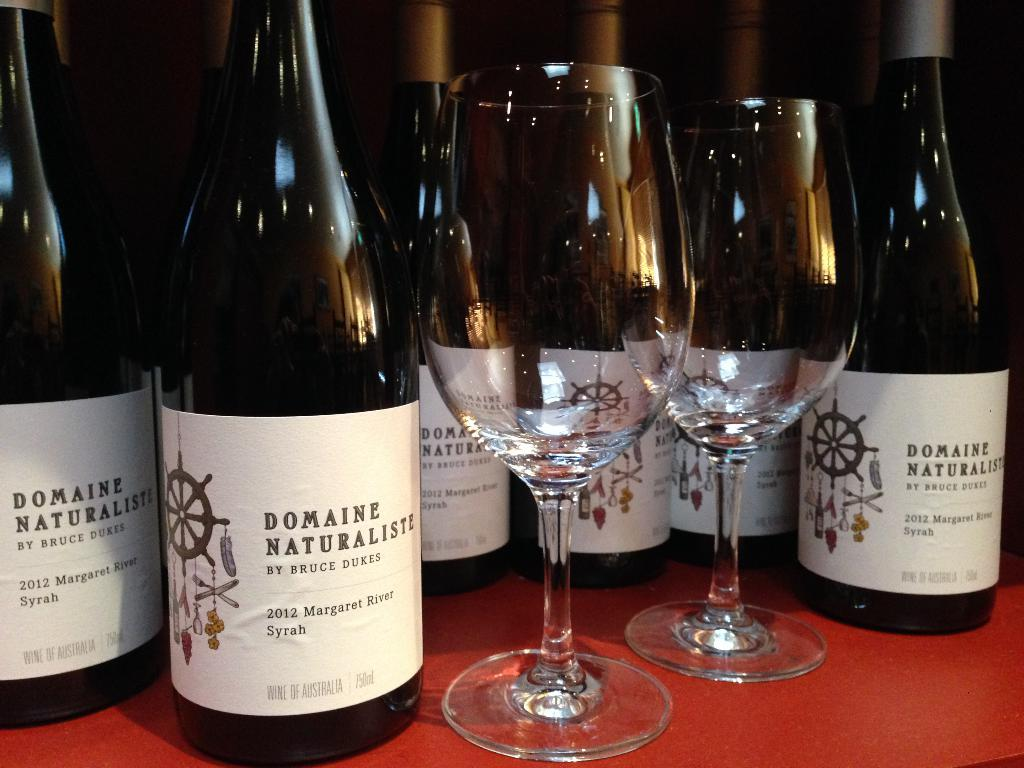<image>
Present a compact description of the photo's key features. The two crystal wineglasses are displayed with six bottles of Domaine Naturaliste wine in the background. 